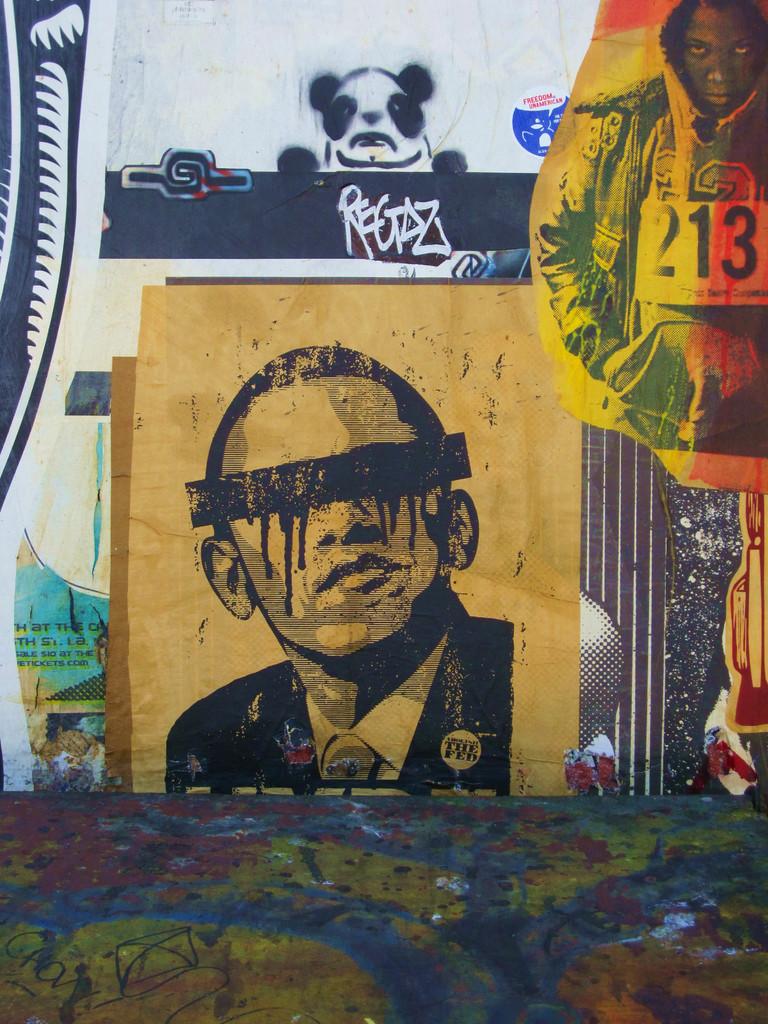What are the 3 numbers?
Offer a terse response. 213. 